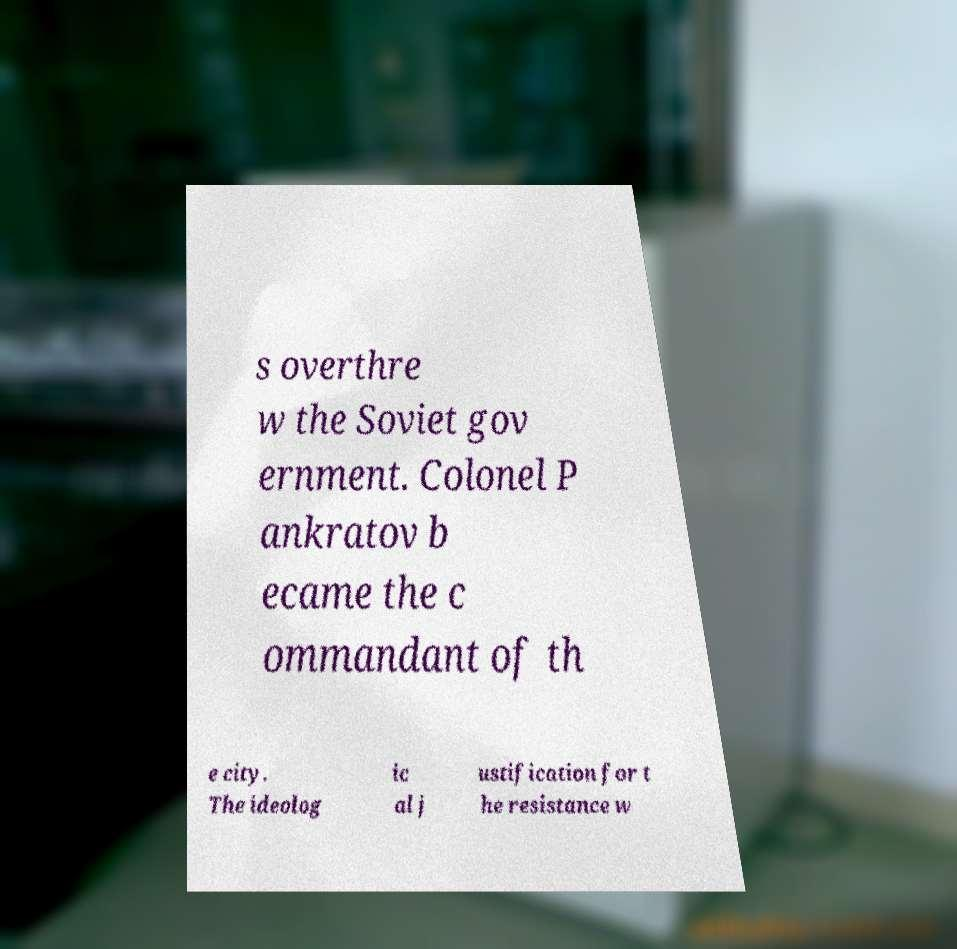Could you assist in decoding the text presented in this image and type it out clearly? s overthre w the Soviet gov ernment. Colonel P ankratov b ecame the c ommandant of th e city. The ideolog ic al j ustification for t he resistance w 